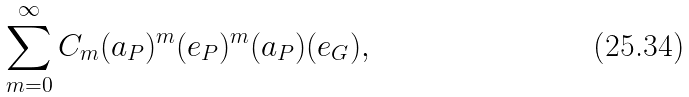<formula> <loc_0><loc_0><loc_500><loc_500>\sum _ { m = 0 } ^ { \infty } C _ { m } ( a _ { P } ) ^ { m } ( e _ { P } ) ^ { m } ( a _ { P } ) ( e _ { G } ) ,</formula> 